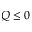<formula> <loc_0><loc_0><loc_500><loc_500>Q \leq 0</formula> 